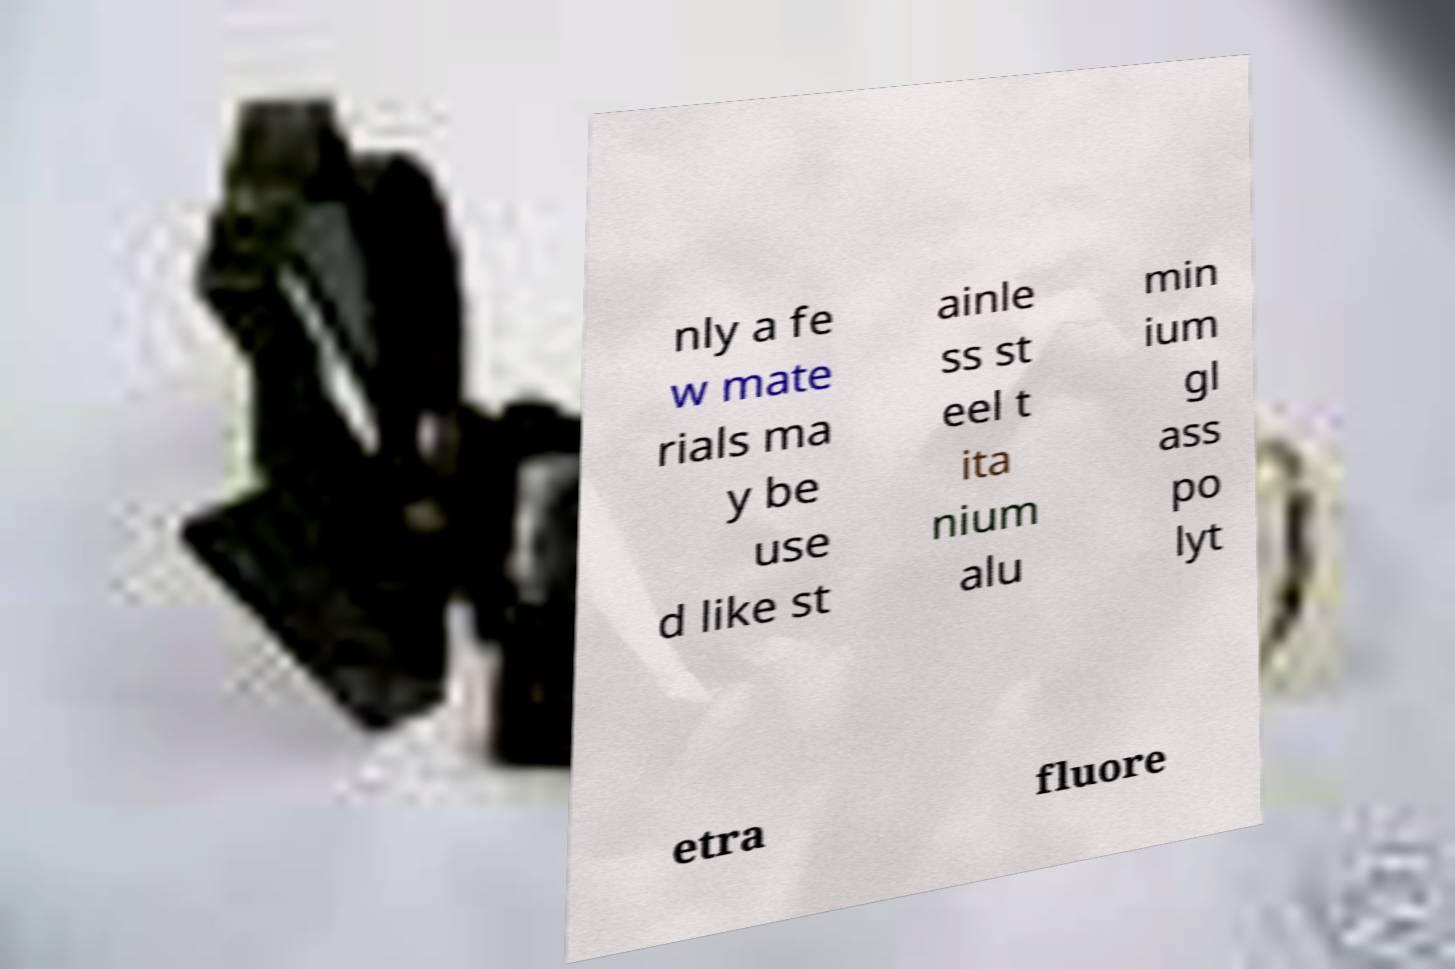Could you assist in decoding the text presented in this image and type it out clearly? nly a fe w mate rials ma y be use d like st ainle ss st eel t ita nium alu min ium gl ass po lyt etra fluore 